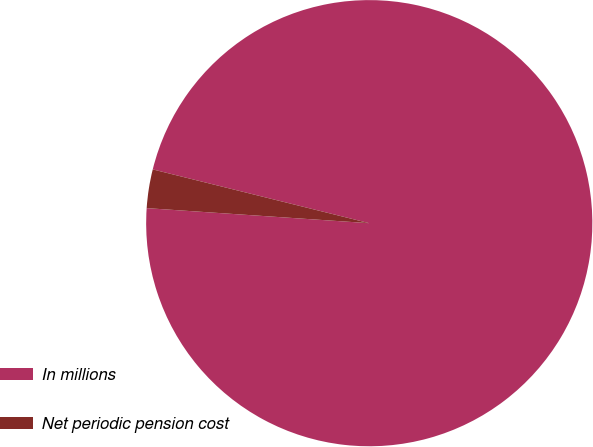Convert chart to OTSL. <chart><loc_0><loc_0><loc_500><loc_500><pie_chart><fcel>In millions<fcel>Net periodic pension cost<nl><fcel>97.2%<fcel>2.8%<nl></chart> 